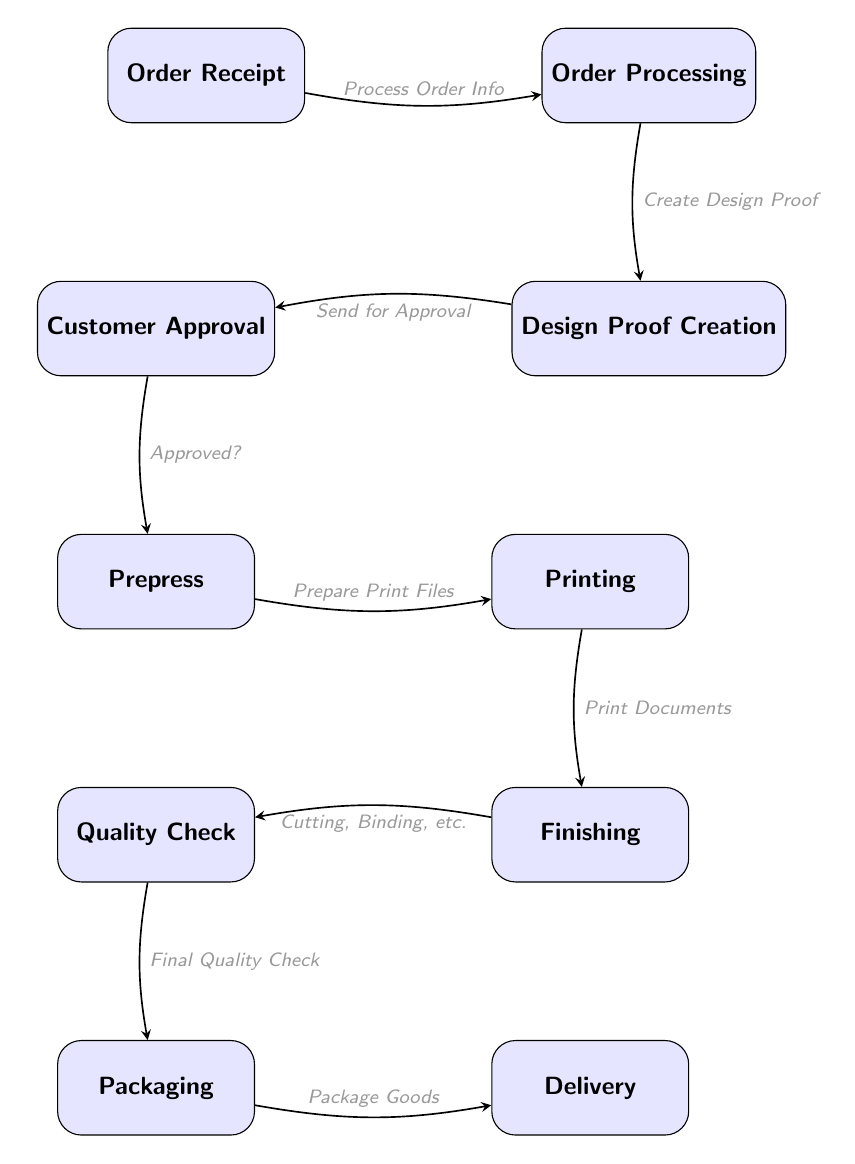What is the first step in the printing process? The first node in the diagram is "Order Receipt," which indicates the initiation of the printing workflow.
Answer: Order Receipt How many total steps are displayed in the diagram? By counting all the nodes shown in the diagram, there are a total of 10 steps: Order Receipt, Order Processing, Design Proof Creation, Customer Approval, Prepress, Printing, Finishing, Quality Check, Packaging, and Delivery.
Answer: 10 What comes after "Design Proof Creation"? The arrow indicates that the next step after "Design Proof Creation" is "Customer Approval," meaning the design proof is sent to the customer for their approval.
Answer: Customer Approval Which step follows "Prepress"? The diagram shows that after "Prepress" comes "Printing," as indicated by the flow of the arrows connecting these two nodes directly.
Answer: Printing What is the final step in the printing process? The last node in the diagram is "Delivery," which represents the completion of the printing workflow with the delivery of goods to the customer.
Answer: Delivery If the customer does not approve the design proof, which step is skipped? If the customer does not approve the design proof, the workflow does not proceed to "Prepress," as the approval is a prerequisite for moving forward in the process.
Answer: Prepress How many edges are there connecting the nodes? Each step is connected by arrows, representing the relationships. Counted, there are 9 edges linking all 10 nodes together.
Answer: 9 Which steps are involved in finishing the printed documents? The "Finishing" step encompasses actions such as cutting, binding, and other processes, as indicated directly in the node labeled "Finishing."
Answer: Cutting, Binding, etc What action occurs after "Quality Check"? After "Quality Check," the next step is "Packaging," which indicates that the goods are packaged for delivery once they have passed quality verification.
Answer: Packaging 